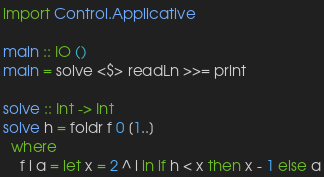<code> <loc_0><loc_0><loc_500><loc_500><_Haskell_>import Control.Applicative

main :: IO ()
main = solve <$> readLn >>= print

solve :: Int -> Int
solve h = foldr f 0 [1..]
  where
    f i a = let x = 2 ^ i in if h < x then x - 1 else a
</code> 